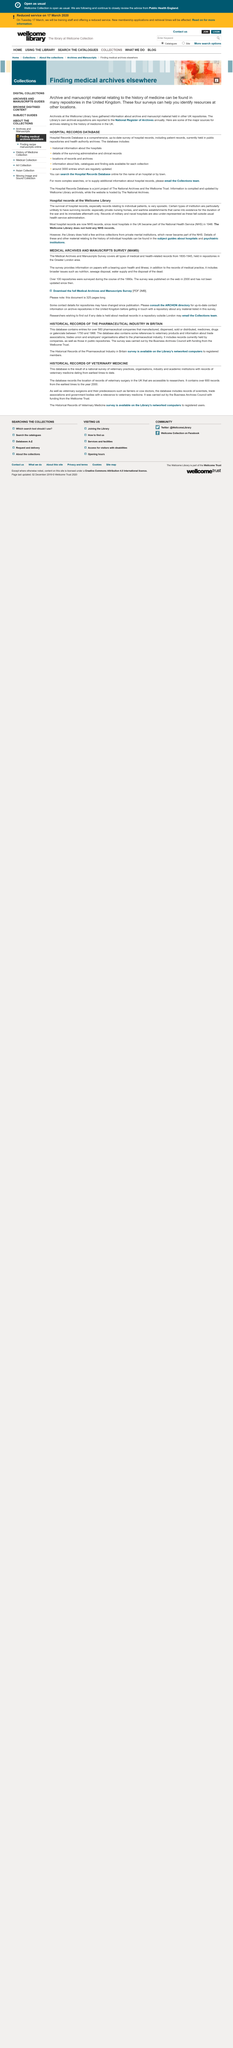Give some essential details in this illustration. The survival of hospital records was very sporadic, and yes, it was. The Historical Records of the Pharmaceutical Industry in Britain contains entries from over 560 companies. Records of military and naval hospitals were not adequately represented due to their classification outside the usual health service administration. In the United Kingdom, archive and manuscript material pertaining to the history of medicine can be found in various repositories. Archivists from the Wellcome Library have gathered information about the archive and manuscript material held in other UK repositories. 